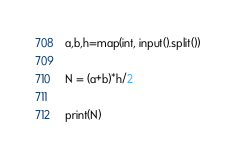<code> <loc_0><loc_0><loc_500><loc_500><_Python_>a,b,h=map(int, input().split())

N = (a+b)*h/2

print(N)
</code> 